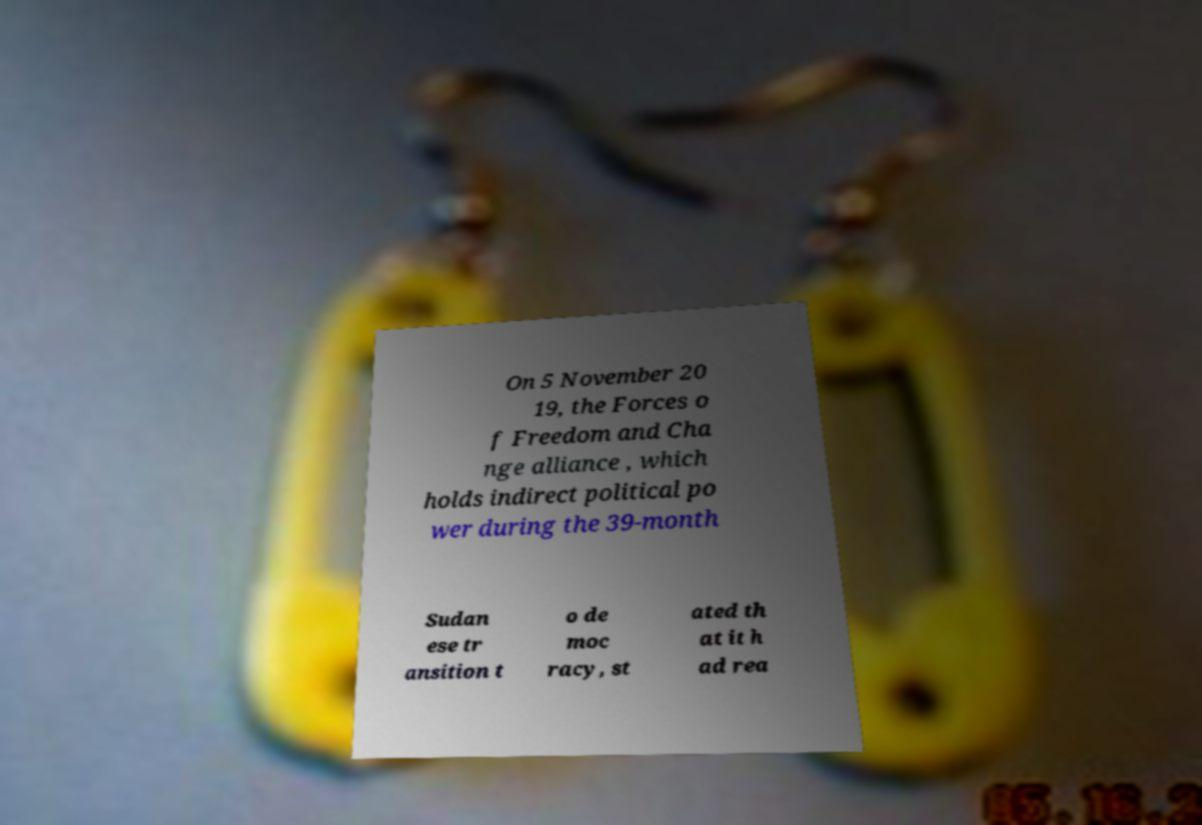Can you read and provide the text displayed in the image?This photo seems to have some interesting text. Can you extract and type it out for me? On 5 November 20 19, the Forces o f Freedom and Cha nge alliance , which holds indirect political po wer during the 39-month Sudan ese tr ansition t o de moc racy, st ated th at it h ad rea 